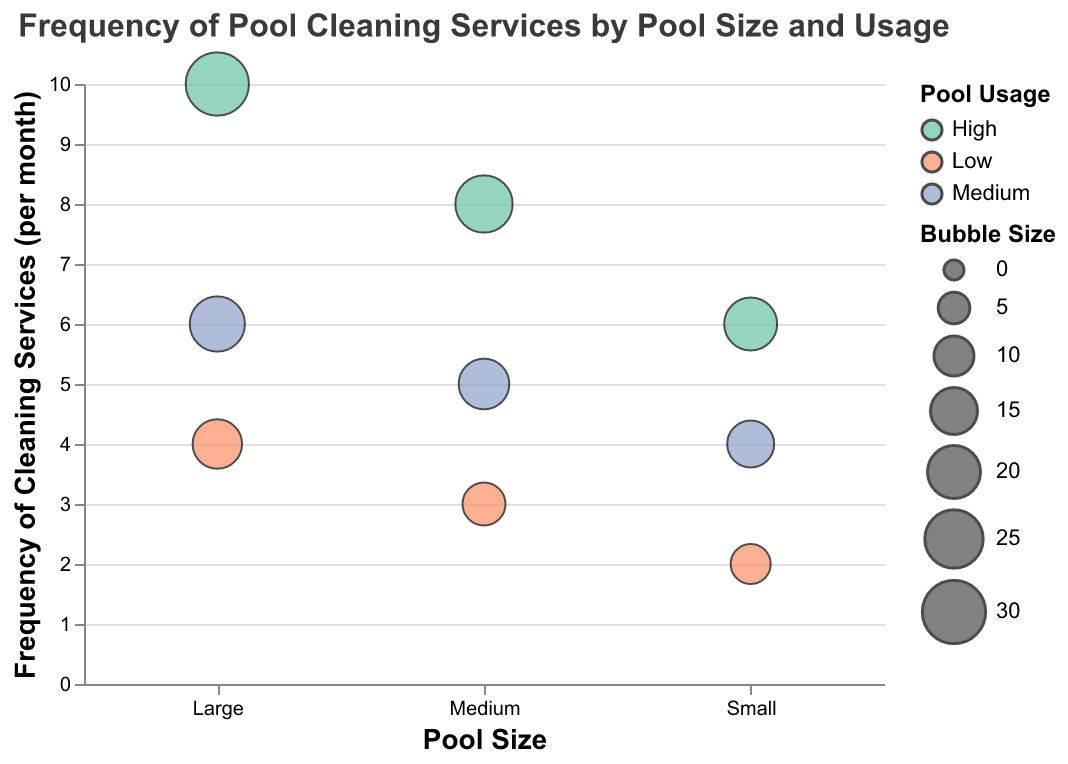What is the title of the bubble chart? The title is displayed at the top of the chart and provides an overview of what the visual represents. In this case, it states that the chart is about the frequency of pool cleaning services required by varying pool sizes and usage levels.
Answer: Frequency of Pool Cleaning Services by Pool Size and Usage How many data points are shown in the chart? By counting each bubble in the chart, we can determine the number of data points. Each bubble represents a unique combination of pool size, usage, and cleaning frequency.
Answer: 9 Which pool size has the highest frequency of cleaning services for high usage? By analyzing the sizes of the bubbles and their positions for "high" usage, the largest value indicates the highest frequency. The largest pool size for high usage shows the highest frequency.
Answer: Large What is the frequency of cleaning services for a medium-sized pool with medium usage? Locate the bubble corresponding to a medium-sized pool and medium usage. The y-axis value of this bubble represents the frequency of cleaning services.
Answer: 5 times per month Compare the frequency of cleaning services for small pools between low and high usage. What is the difference? Check the y-axis values for bubbles representing small pools at low and high usage levels. Subtract the lower value from the higher value to find the difference. Low usage for small pools needs 2 services, while high usage needs 6 services. The difference is 6 - 2.
Answer: 4 Which pool size and usage combination requires the maximum frequency of cleaning services? Identify the bubble that reaches the highest value on the y-axis and check its corresponding pool size and usage level. This highest bubble represents large pools with high usage which have the maximum frequency.
Answer: Large pools with high usage What is the average frequency of cleaning services required for medium-sized pools across all usage levels? Add the frequencies for low, medium, and high usage levels for medium-sized pools and divide by the number of these levels. (3 + 5 + 8)/3 = 16/3
Answer: Approximately 5.33 times per month For which pool size does medium usage have a bubble size of 22? The given bubble size is a distinguishing feature, and we match it with the medium usage level bubble for different pool sizes. We then find that large pools with medium usage have a bubble size of 22.
Answer: Large What is the relationship between pool usage level and frequency of cleaning services for medium-sized pools? Examine the y-axis values of the bubbles representing medium-sized pools with different usage levels. As pool usage increases from low to high, the frequency of cleaning services also increases. Low usage is 3, medium usage is 5, and high usage is 8. The relationship indicates a positive correlation.
Answer: Higher usage leads to higher cleaning frequency 